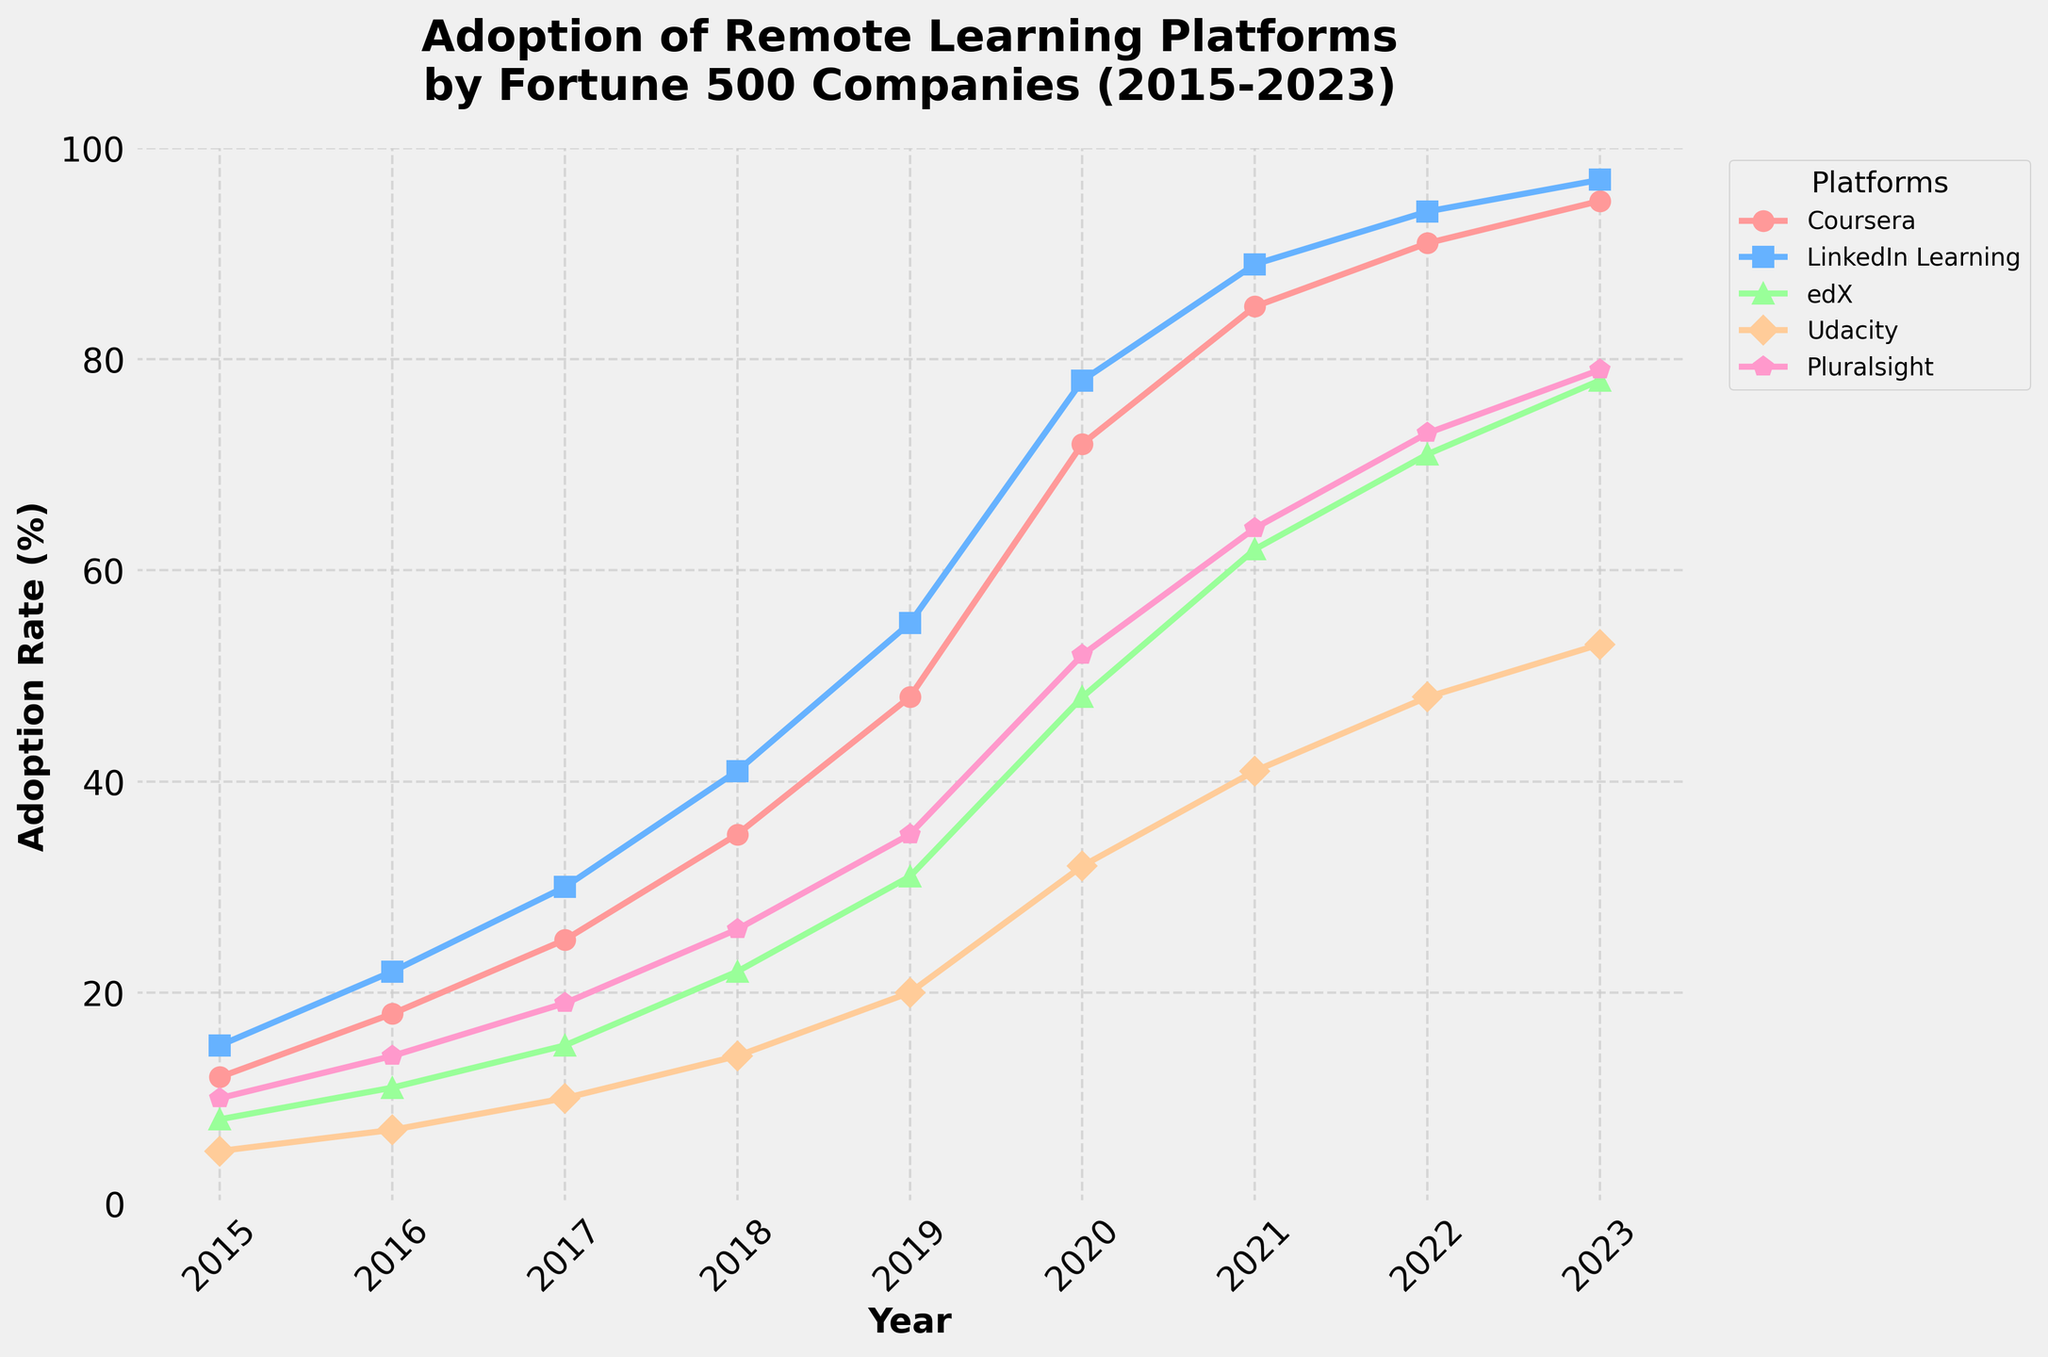What is the trend in the adoption rate of Coursera from 2015 to 2023? Observing the trend of Coursera on the chart, we can see that the adoption rate has consistently increased from 12% in 2015 to 95% in 2023.
Answer: A consistent increase Which platform had the highest adoption rate in 2023? Looking at the endpoints of all line graphs in 2023, LinkedIn Learning shows the highest adoption rate at 97%.
Answer: LinkedIn Learning Between which years did LinkedIn Learning have the highest increase in adoption rate? By examining the slope of the LinkedIn Learning line, the steepest increase appears between 2018 and 2019, where it jumped from 41% to 55%.
Answer: 2018 to 2019 How do the adoption rates of Coursera and Udacity compare in 2018? By checking the adoption rates of Coursera and Udacity in 2018 on the chart, Coursera is at 35% while Udacity is at 14%. Thus, Coursera has a higher adoption rate.
Answer: Coursera is higher What is the average adoption rate of Pluralsight from 2015 to 2023? Summing the adoption rates for Pluralsight from 2015 to 2023 (10, 14, 19, 26, 35, 52, 64, 73, 79) gives 372. Dividing by the 9 data points, the average is approximately 41.33%.
Answer: Approximately 41.33% By what percentage did edX's adoption rate increase from 2020 to 2023? The adoption rate for edX in 2020 was 48% and in 2023 it was 78%. The percentage increase is calculated by (78 - 48) / 48 * 100, which equals 62.5%.
Answer: 62.5% Which platform had the smallest increase in adoption rate from 2016 to 2017? Comparing the differences from 2016 to 2017: Coursera (7), LinkedIn Learning (8), edX (4), Udacity (3), Pluralsight (5). Udacity had the smallest increase.
Answer: Udacity Which year saw the first time Coursera's adoption rate exceeded 50%? By tracking Coursera's line, the first time it exceeds 50% is in 2019, where the rate was 48% the previous year and 72% that year.
Answer: 2019 How does the adoption rate growth of Pluralsight from 2021 to 2023 compare to Coursera in the same period? Pluralsight grew from 64% in 2021 to 79% in 2023, a 15% increase. Coursera grew from 85% to 95%, a 10% increase.
Answer: Pluralsight had a larger increase What's the combined adoption rate for all platforms in 2020? Summing the adoption rates in 2020: Coursera (72), LinkedIn Learning (78), edX (48), Udacity (32), Pluralsight (52). The total is 282.
Answer: 282 